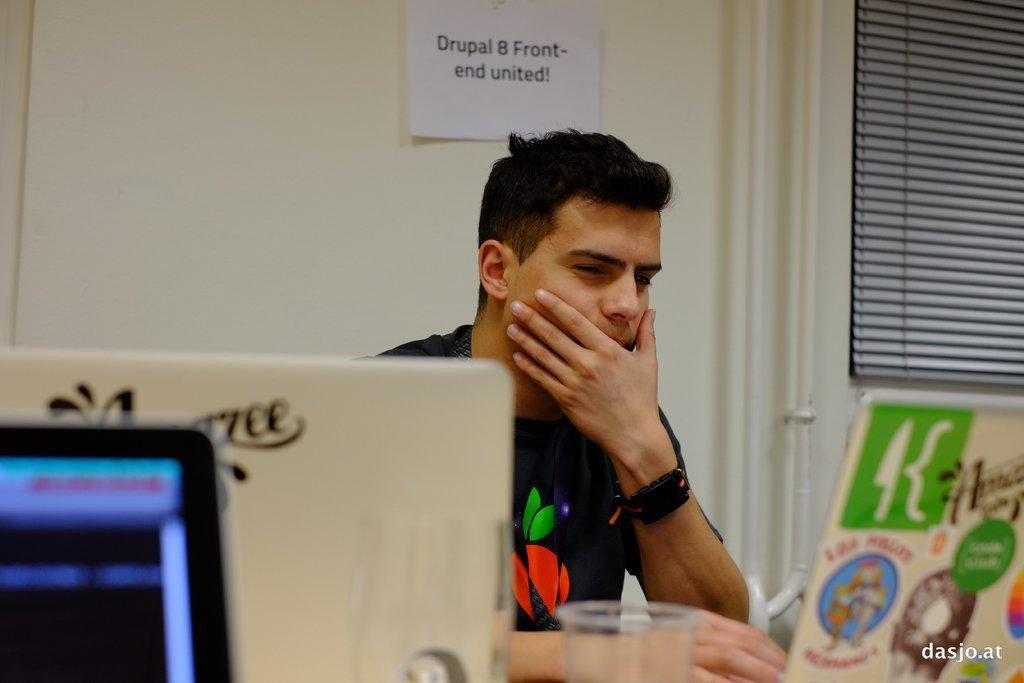Could you give a brief overview of what you see in this image? This is the man sitting. I think these are the three laptops and a plastic glass. This is the paper attached to the wall. I can see the pipes attached to the wall. This looks like a curtain. This is the watermark on the image. 